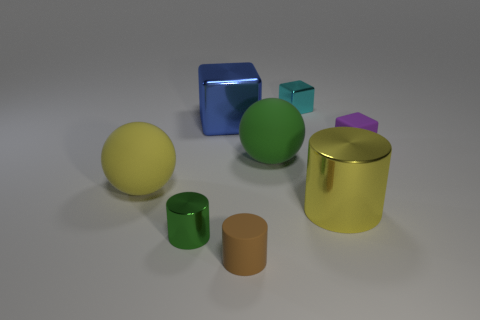Add 1 small green matte things. How many objects exist? 9 Subtract all cubes. How many objects are left? 5 Add 6 spheres. How many spheres exist? 8 Subtract 0 blue balls. How many objects are left? 8 Subtract all tiny green metallic cylinders. Subtract all small objects. How many objects are left? 3 Add 3 yellow rubber balls. How many yellow rubber balls are left? 4 